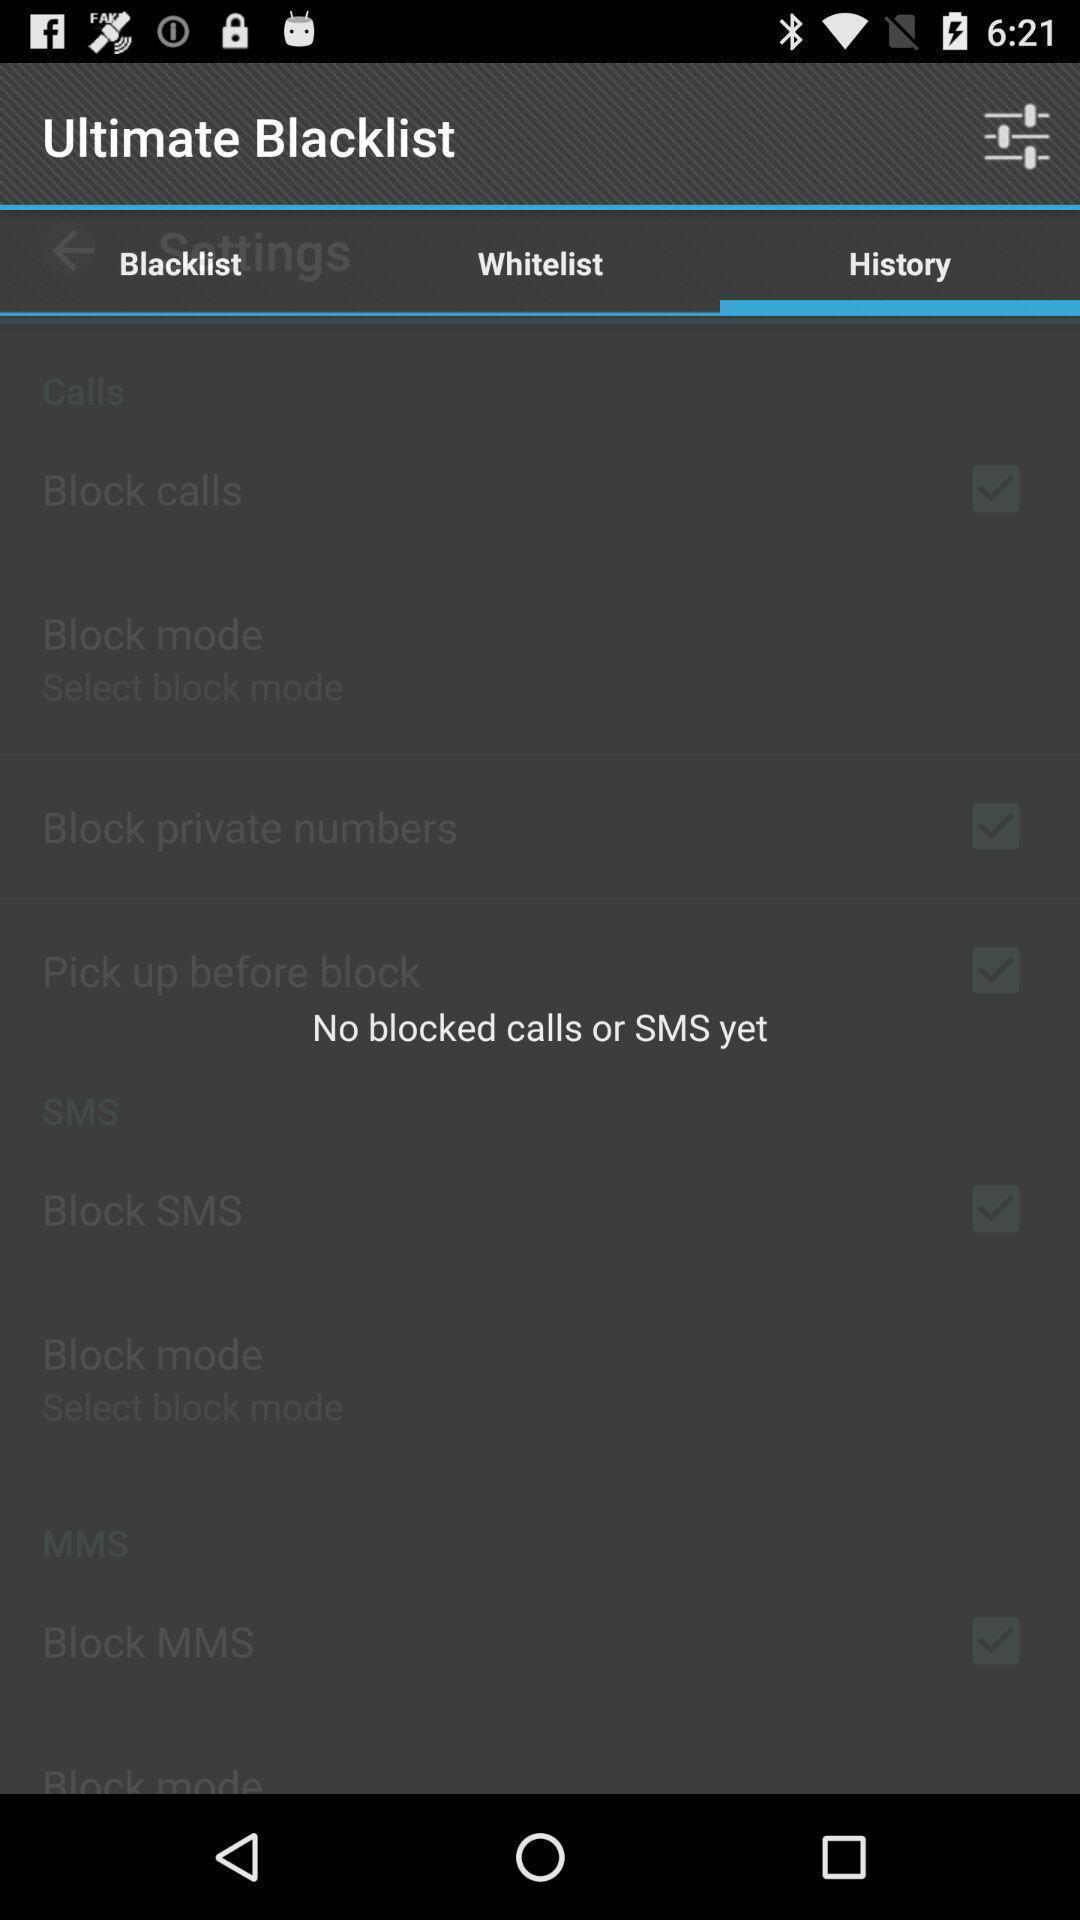Summarize the main components in this picture. Screen displaying the history page. 